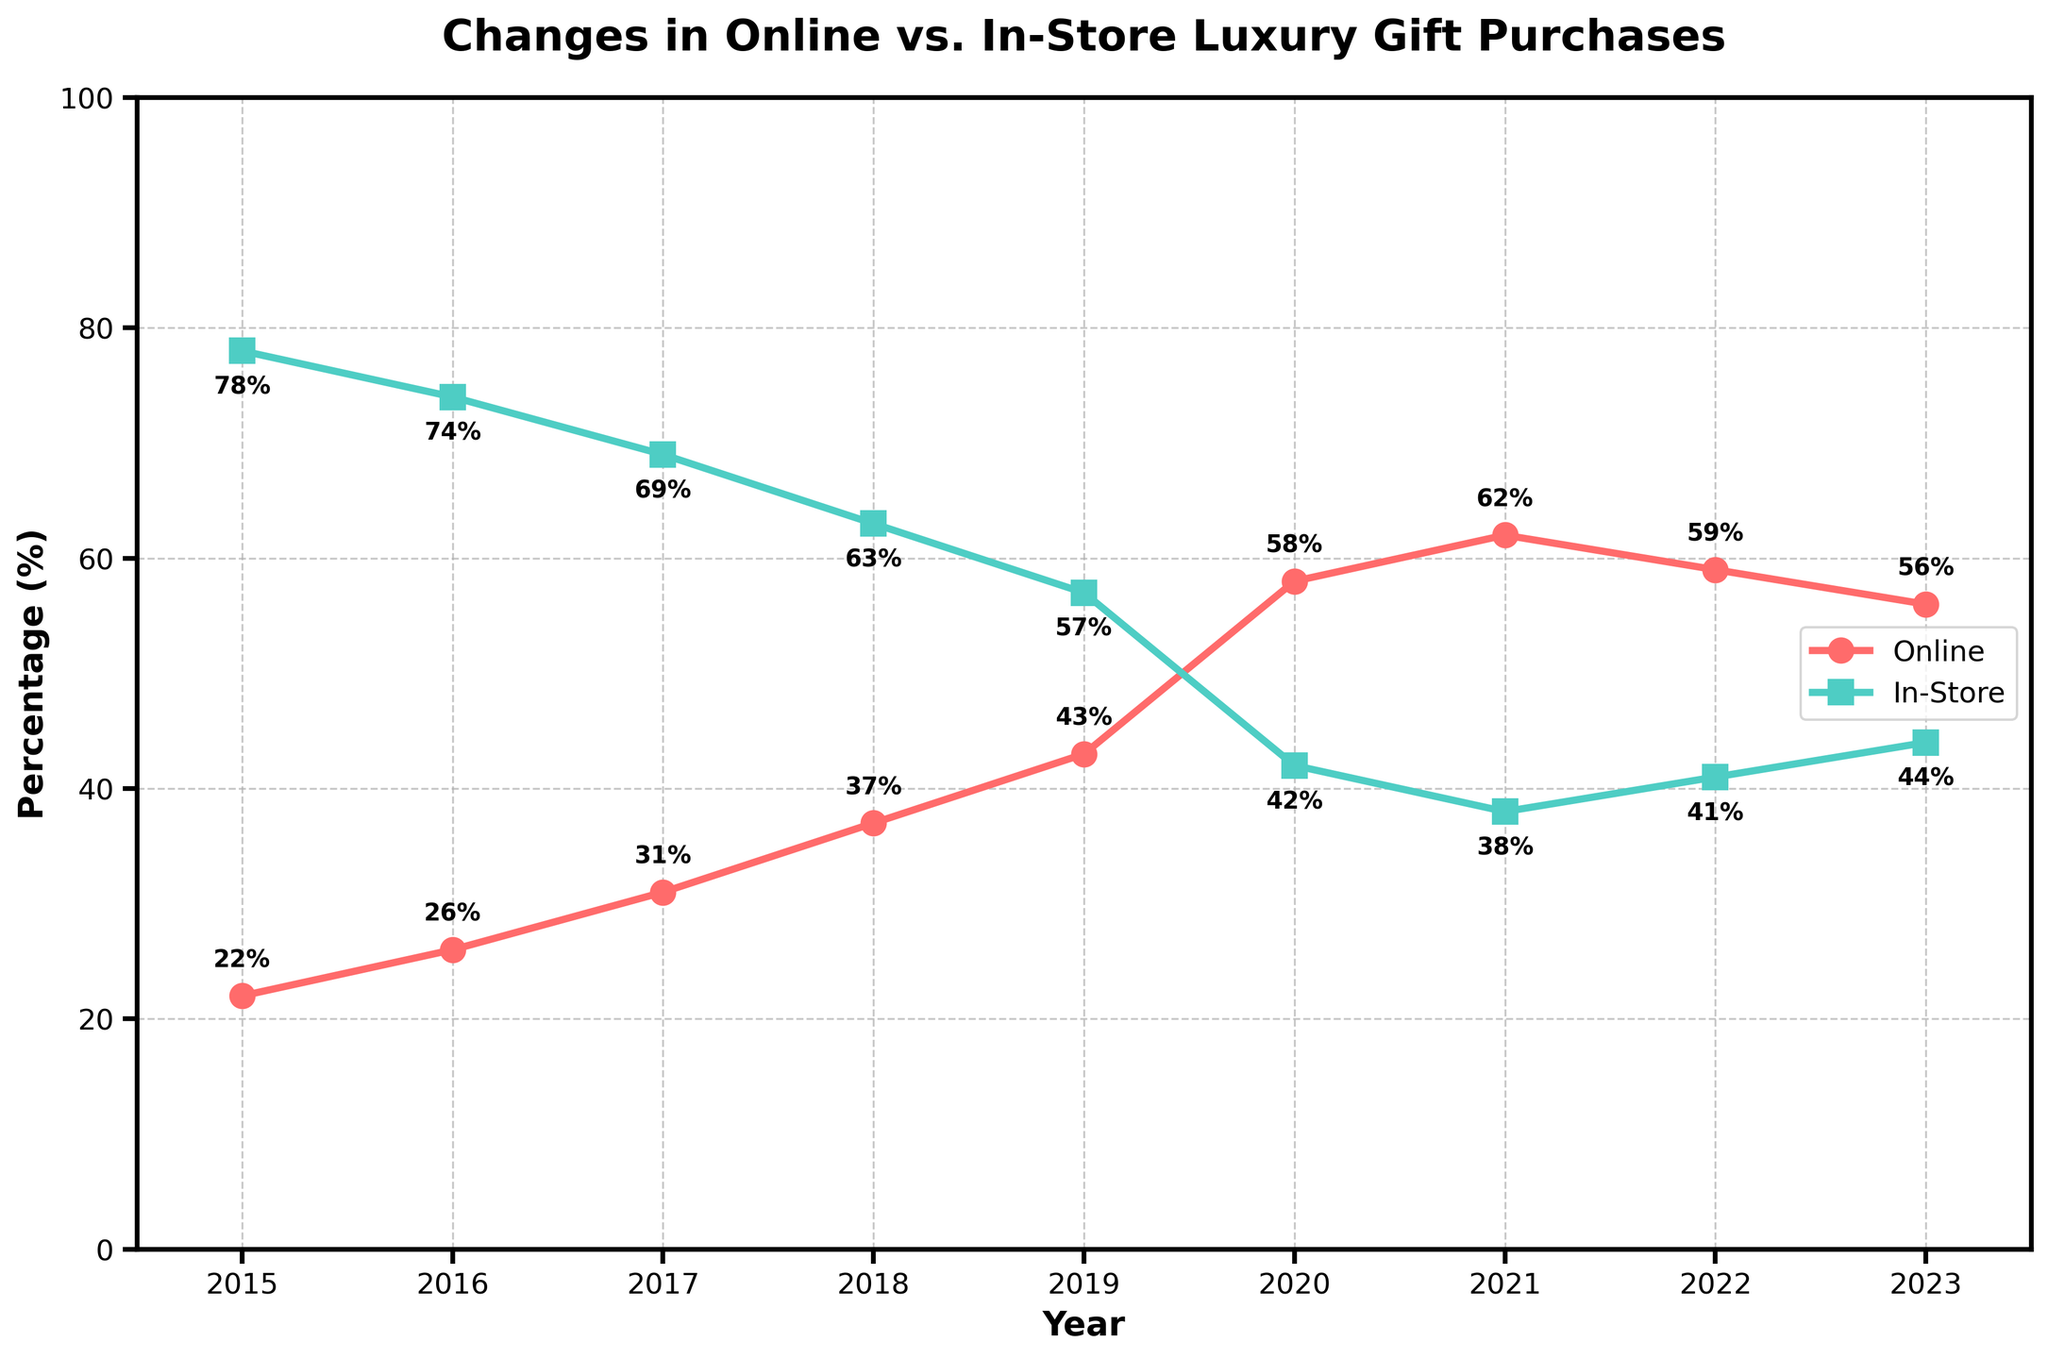What trend can be observed in the percentage of online luxury gift purchases from 2015 to 2018? The line representing online luxury gift purchases shows an increasing trend from 22% in 2015 to 37% in 2018.
Answer: Increasing trend Which year shows the highest percentage of online luxury gift purchases? By looking at the red line (Online) and its annotated values, the highest percentage for online luxury gift purchases is 62% in 2021.
Answer: 2021 How did the percentage of in-store luxury gift purchases change between 2019 and 2020? The green line (In-Store) shows a decrease from 57% in 2019 to 42% in 2020.
Answer: Decreased In which year did online luxury gift purchases surpass in-store luxury gift purchases? Observe the points where the red line (Online) goes above the green line (In-Store). This happens in 2020 when online is at 58% and in-store is at 42%.
Answer: 2020 Compare the percentage differences between online and in-store luxury gift purchases in 2017. In 2017, online purchases were 31% and in-store purchases were 69%. The difference is 69% - 31% = 38%.
Answer: 38% What is the average percentage of online luxury gift purchases from 2015 to 2023? Sum the percentages of online luxury gift purchases for all years 2015-2023 (22 + 26 + 31 + 37 + 43 + 58 + 62 + 59 + 56) and divide by 9. The answer is (22+26+31+37+43+58+62+59+56)/9 = 43.78%.
Answer: 43.78% Between 2022 and 2023, did the percentage of online luxury gift purchases increase or decrease? The red line (Online) shows a decrease from 59% in 2022 to 56% in 2023.
Answer: Decrease What's the visual representation used to indicate online luxury gift purchases on the chart? The chart uses a red line with circular markers to represent online luxury gift purchases.
Answer: Red line with circular markers What was the first year when the percentage of online luxury gift purchases reached 50% or above? The red line (Online) reaches 58% in 2020, marking the first instance of 50% or above.
Answer: 2020 What percentage difference can you observe in online luxury gift purchases between 2021 and 2023? Online luxury gift purchases were 62% in 2021 and 56% in 2023. The difference is 62% - 56% = 6%.
Answer: 6% 